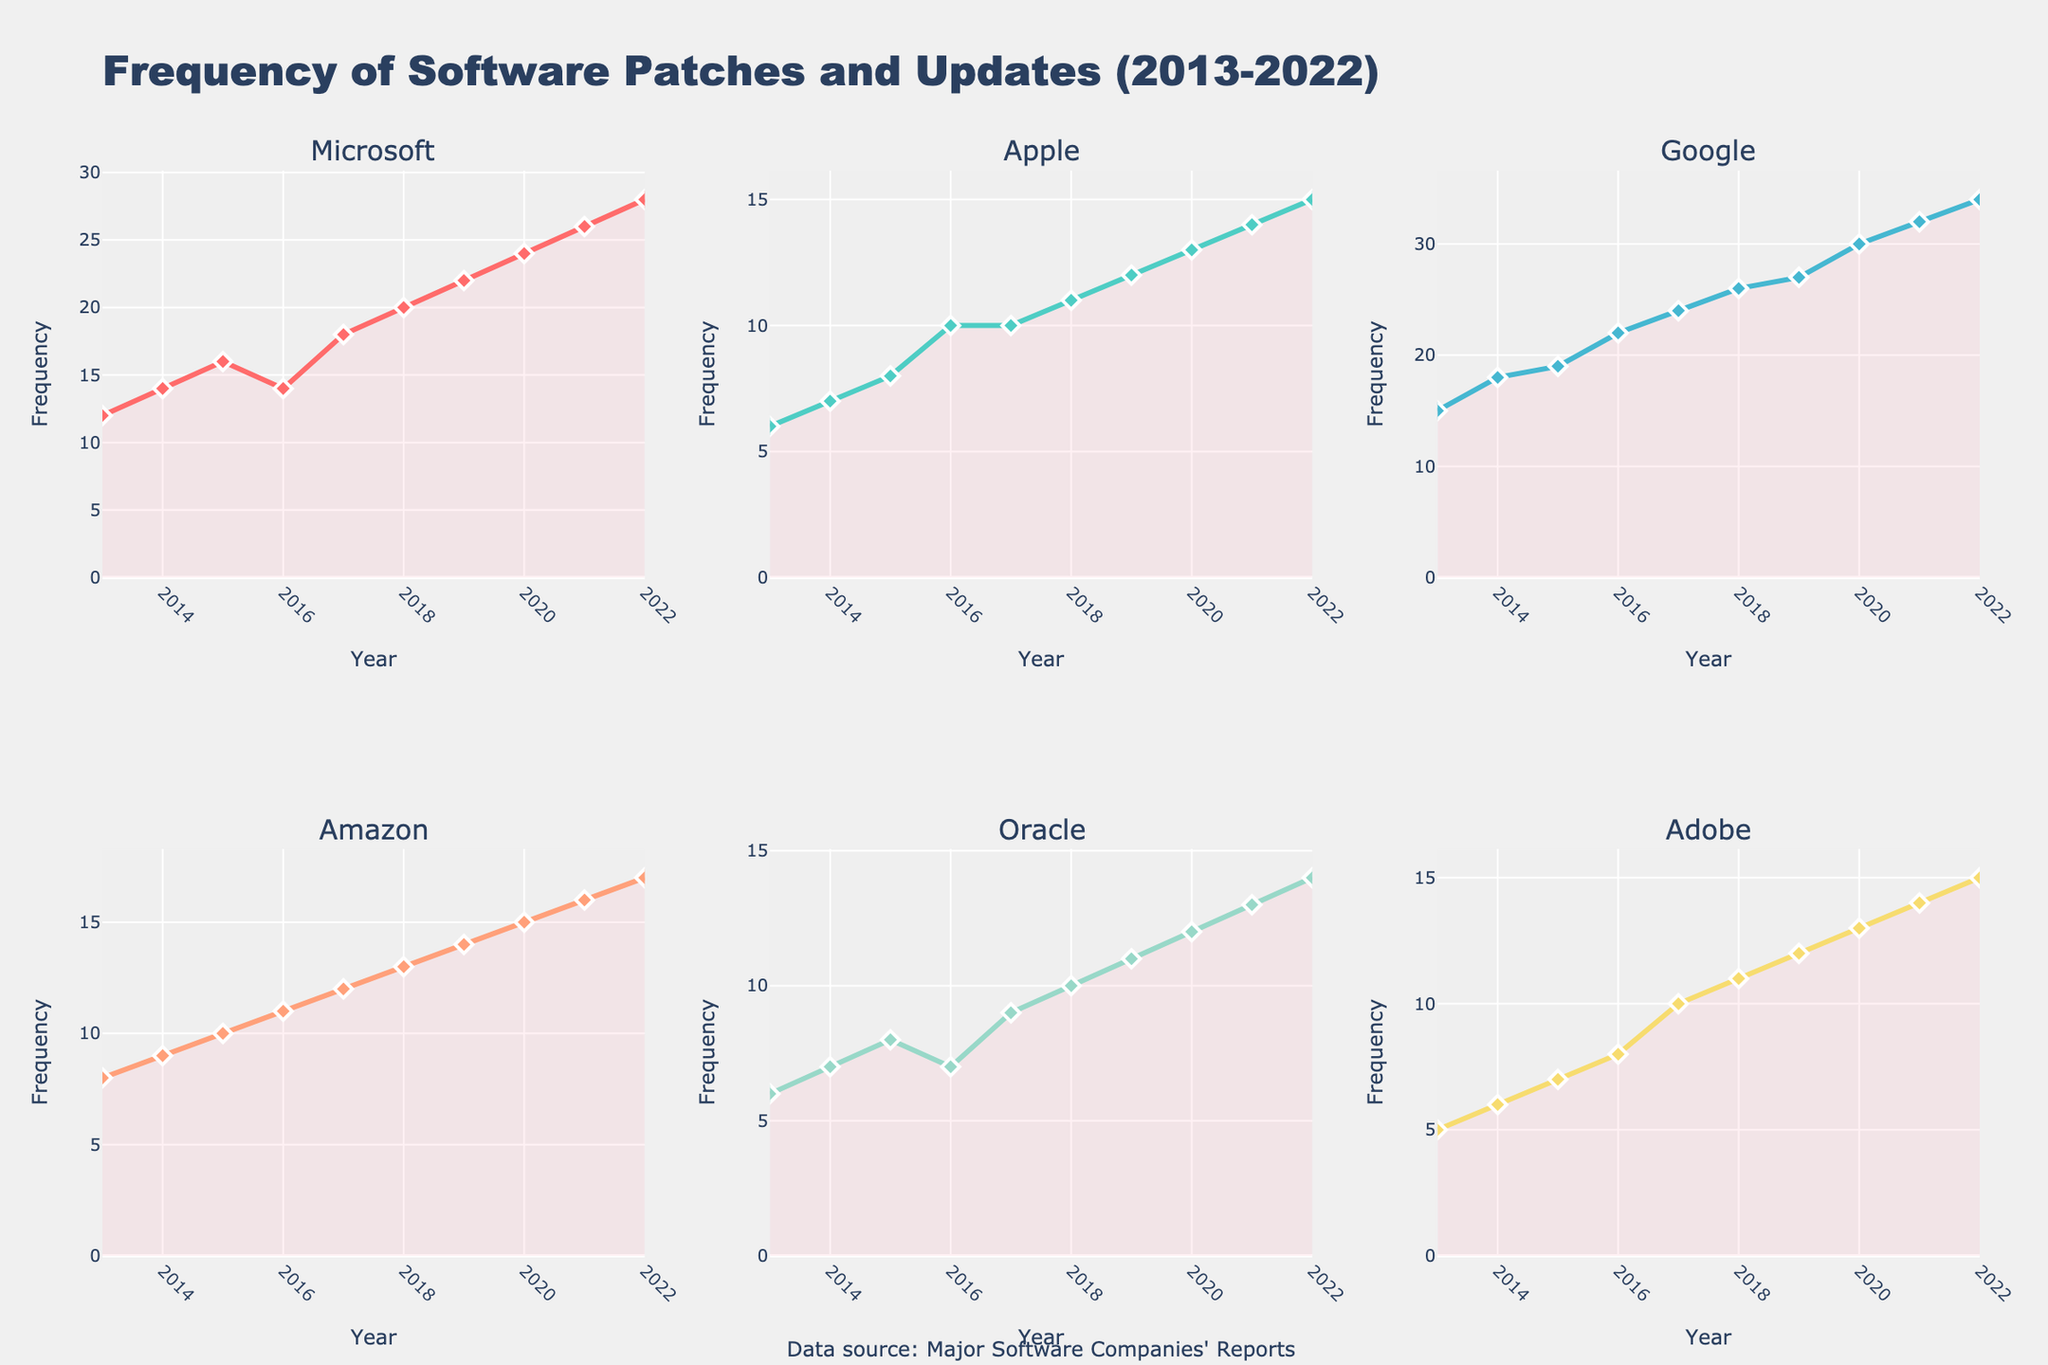What's the title of the plot? The title is displayed at the top of the figure. It reads "Frequency of Software Patches and Updates (2013-2022)".
Answer: Frequency of Software Patches and Updates (2013-2022) Which company released the most patches and updates in 2022? By looking at the points for 2022 in each subplot, Microsoft has the highest value at that year with 28 updates.
Answer: Microsoft How many software patches and updates did Apple release in 2017? Find the point corresponding to 2017 on Apple’s subplot and read the value, which is 10.
Answer: 10 What is the average number of patches and updates released by Google over the decade? Sum the yearly values for Google from 2013 to 2022: 15 + 18 + 19 + 22 + 24 + 26 + 27 + 30 + 32 + 34 = 247. Then divide by 10 years.
Answer: 24.7 By how many updates did Amazon's frequency increase from 2013 to 2022? Subtract Amazon's 2013 value (8) from its 2022 value (17). 17 - 8 = 9.
Answer: 9 Which two companies had the same frequency of software patches and updates in 2016? Compare the values for 2016 across all companies and identify those with the same value, which are Microsoft and Oracle both with 14 updates.
Answer: Microsoft and Oracle In which year did Adobe release more patches than Oracle for the first time? Compare the yearly values for Adobe and Oracle starting from 2013. Adobe surpasses Oracle in frequency in 2017.
Answer: 2017 What is the total number of software patches and updates released by Microsoft from 2013 to 2022? Sum the yearly values for Microsoft from 2013 to 2022: 12 + 14 + 16 + 14 + 18 + 20 + 22 + 24 + 26 + 28 = 194.
Answer: 194 Which company's updates increased most consistently over the years? By inspecting the trends, Google shows a consistent year-by-year increase in the number of patches and updates.
Answer: Google What's the difference between the number of patches and updates released by Apple and Adobe in 2020? Subtract Apple's value (13) from Adobe's value (13) for 2020. 13 - 13 = 0.
Answer: 0 